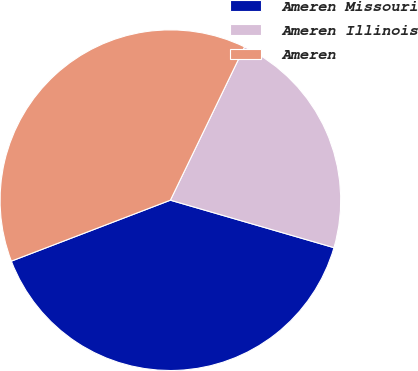Convert chart to OTSL. <chart><loc_0><loc_0><loc_500><loc_500><pie_chart><fcel>Ameren Missouri<fcel>Ameren Illinois<fcel>Ameren<nl><fcel>39.68%<fcel>22.33%<fcel>37.99%<nl></chart> 